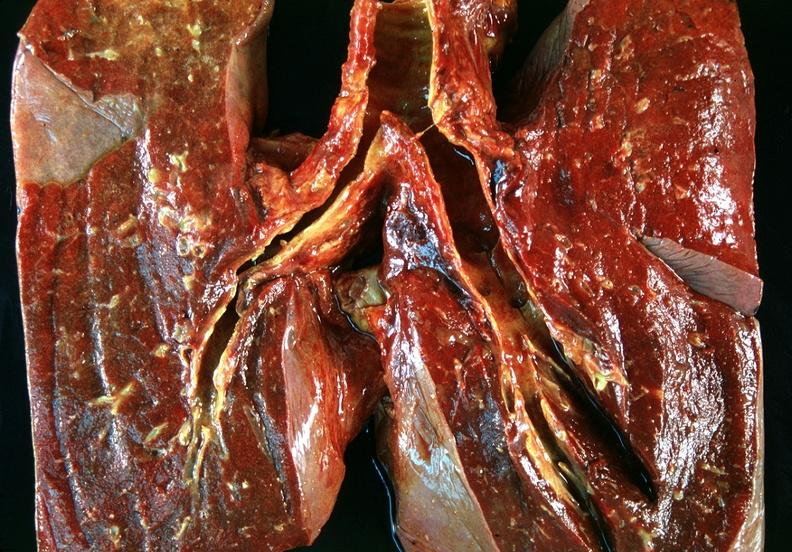s respiratory present?
Answer the question using a single word or phrase. Yes 